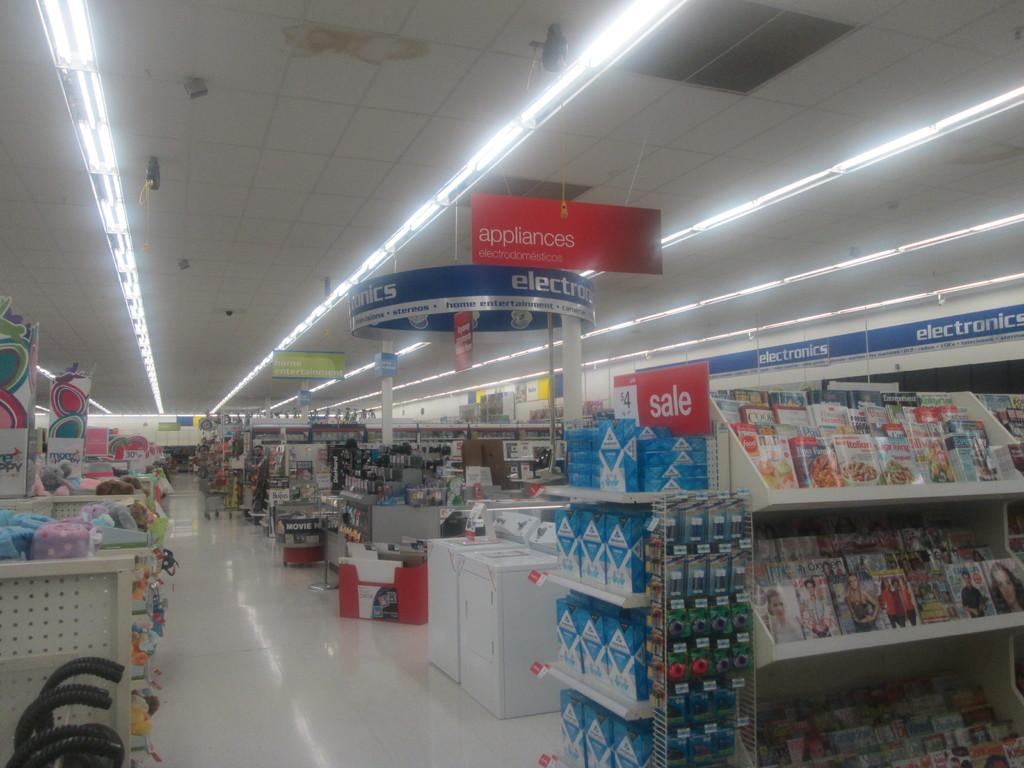Provide a one-sentence caption for the provided image. The appliances section of a store is right next to the electronics department. 